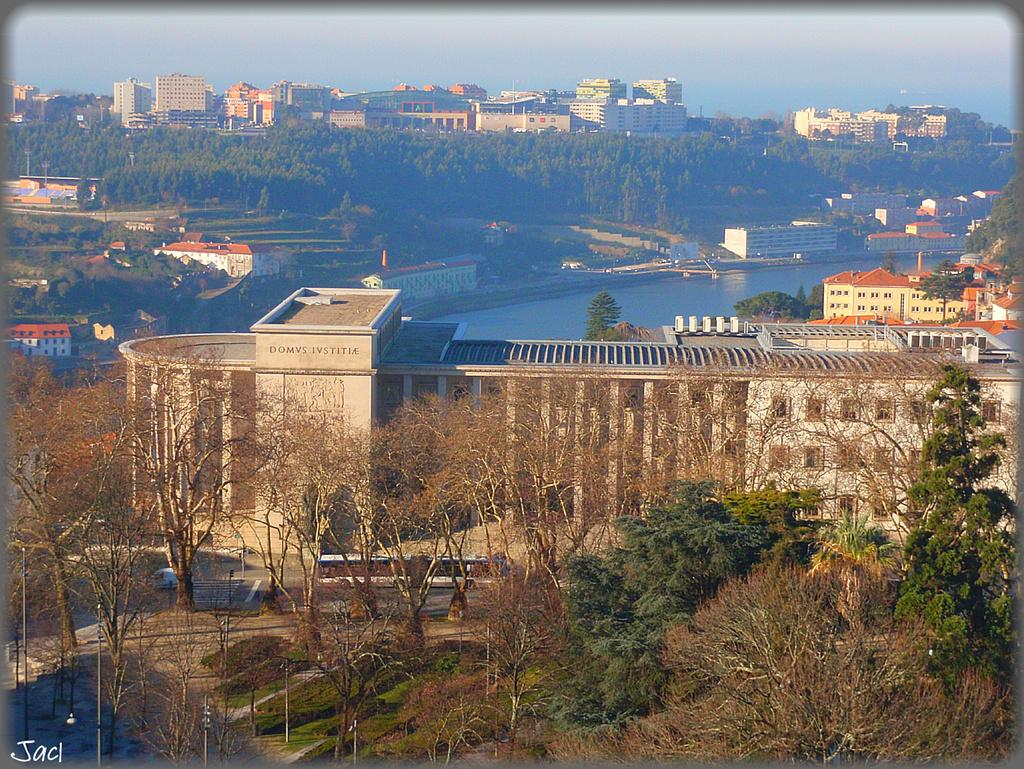What type of natural elements can be seen in the image? There are trees in the image. What type of man-made structures are present in the image? There is a building and additional buildings in the image. What body of water is visible in the image? There is a lake in the image. What is the condition of the sky in the image? The sky is clear in the image. What type of mouth can be seen on the trees in the image? There are no mouths present on the trees in the image, as trees do not have mouths. Is there any ice visible in the image? There is no ice visible in the image. 